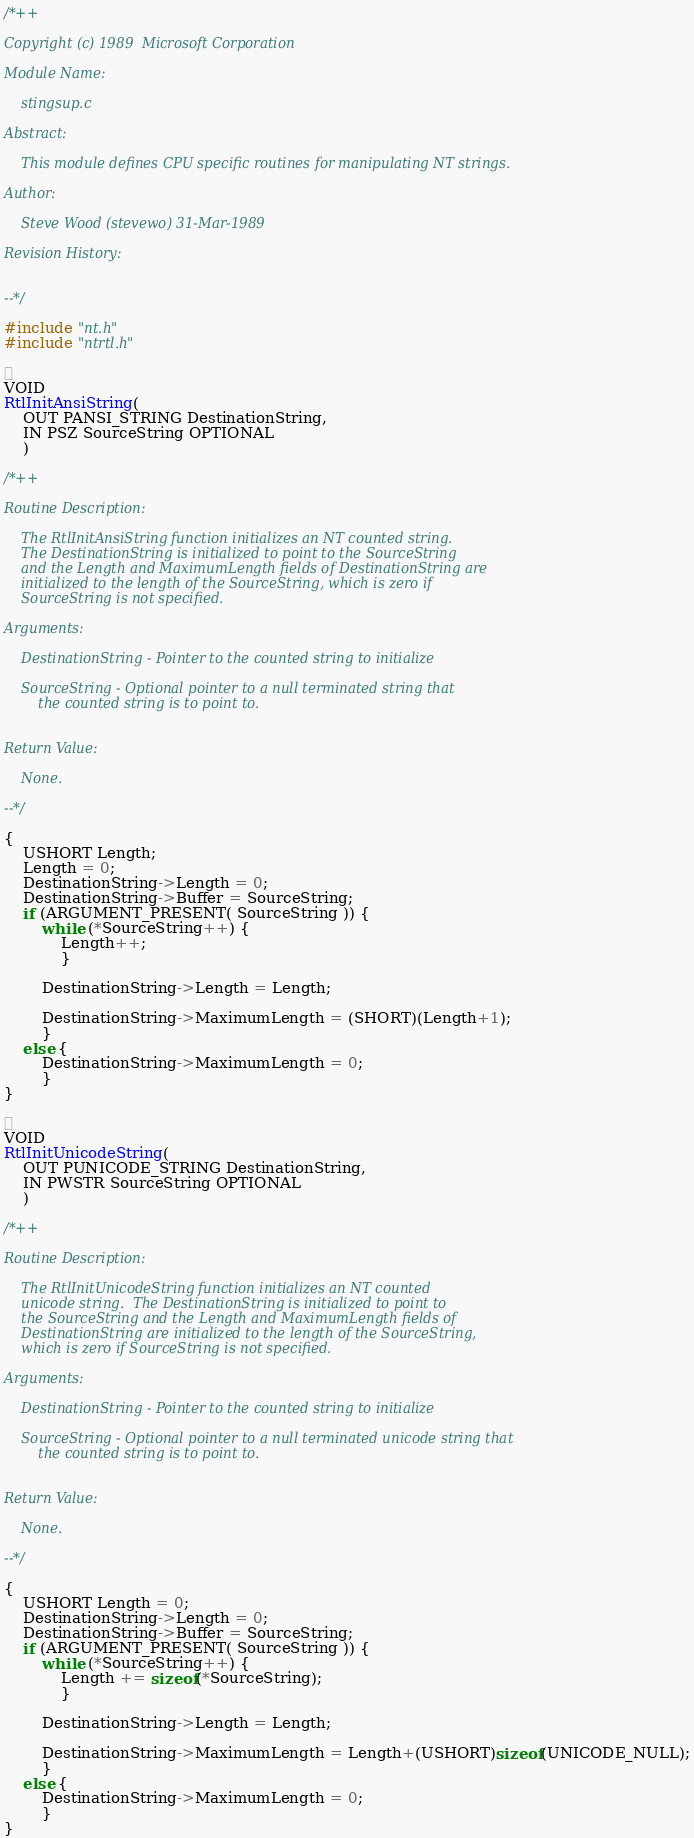Convert code to text. <code><loc_0><loc_0><loc_500><loc_500><_C_>/*++

Copyright (c) 1989  Microsoft Corporation

Module Name:

    stingsup.c

Abstract:

    This module defines CPU specific routines for manipulating NT strings.

Author:

    Steve Wood (stevewo) 31-Mar-1989

Revision History:


--*/

#include "nt.h"
#include "ntrtl.h"


VOID
RtlInitAnsiString(
    OUT PANSI_STRING DestinationString,
    IN PSZ SourceString OPTIONAL
    )

/*++

Routine Description:

    The RtlInitAnsiString function initializes an NT counted string.
    The DestinationString is initialized to point to the SourceString
    and the Length and MaximumLength fields of DestinationString are
    initialized to the length of the SourceString, which is zero if
    SourceString is not specified.

Arguments:

    DestinationString - Pointer to the counted string to initialize

    SourceString - Optional pointer to a null terminated string that
        the counted string is to point to.


Return Value:

    None.

--*/

{
    USHORT Length;
    Length = 0;
    DestinationString->Length = 0;
    DestinationString->Buffer = SourceString;
    if (ARGUMENT_PRESENT( SourceString )) {
        while (*SourceString++) {
            Length++;
            }

        DestinationString->Length = Length;

        DestinationString->MaximumLength = (SHORT)(Length+1);
        }
    else {
        DestinationString->MaximumLength = 0;
        }
}


VOID
RtlInitUnicodeString(
    OUT PUNICODE_STRING DestinationString,
    IN PWSTR SourceString OPTIONAL
    )

/*++

Routine Description:

    The RtlInitUnicodeString function initializes an NT counted
    unicode string.  The DestinationString is initialized to point to
    the SourceString and the Length and MaximumLength fields of
    DestinationString are initialized to the length of the SourceString,
    which is zero if SourceString is not specified.

Arguments:

    DestinationString - Pointer to the counted string to initialize

    SourceString - Optional pointer to a null terminated unicode string that
        the counted string is to point to.


Return Value:

    None.

--*/

{
    USHORT Length = 0;
    DestinationString->Length = 0;
    DestinationString->Buffer = SourceString;
    if (ARGUMENT_PRESENT( SourceString )) {
        while (*SourceString++) {
            Length += sizeof(*SourceString);
            }

        DestinationString->Length = Length;

        DestinationString->MaximumLength = Length+(USHORT)sizeof(UNICODE_NULL);
        }
    else {
        DestinationString->MaximumLength = 0;
        }
}
</code> 